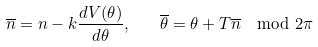<formula> <loc_0><loc_0><loc_500><loc_500>\overline { n } = { n } - k \frac { d V ( \theta ) } { d \theta } , \quad \overline { \theta } = \theta + T \overline { n } \mod 2 \pi</formula> 